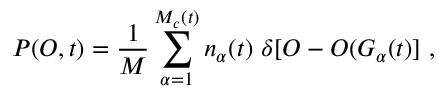<formula> <loc_0><loc_0><loc_500><loc_500>P ( O , t ) = \frac { 1 } { M } \sum _ { \alpha = 1 } ^ { M _ { c } ( t ) } n _ { \alpha } ( t ) \ \delta [ O - O ( G _ { \alpha } ( t ) ] \ ,</formula> 